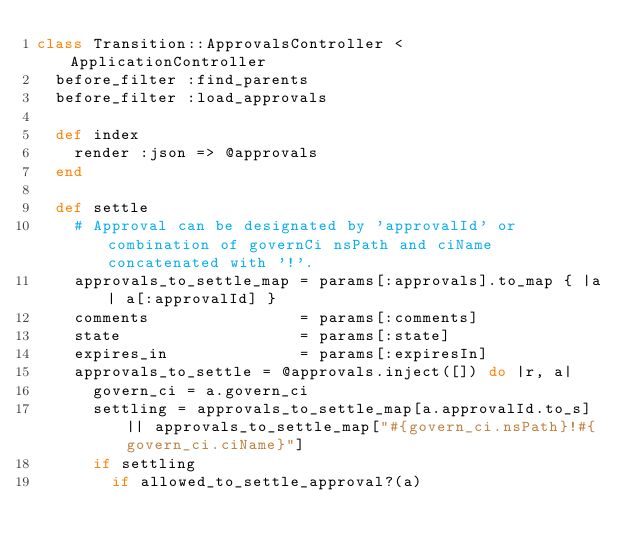<code> <loc_0><loc_0><loc_500><loc_500><_Ruby_>class Transition::ApprovalsController < ApplicationController
  before_filter :find_parents
  before_filter :load_approvals

  def index
    render :json => @approvals
  end

  def settle
    # Approval can be designated by 'approvalId' or combination of governCi nsPath and ciName concatenated with '!'.
    approvals_to_settle_map = params[:approvals].to_map { |a| a[:approvalId] }
    comments                = params[:comments]
    state                   = params[:state]
    expires_in              = params[:expiresIn]
    approvals_to_settle = @approvals.inject([]) do |r, a|
      govern_ci = a.govern_ci
      settling = approvals_to_settle_map[a.approvalId.to_s] || approvals_to_settle_map["#{govern_ci.nsPath}!#{govern_ci.ciName}"]
      if settling
        if allowed_to_settle_approval?(a)</code> 